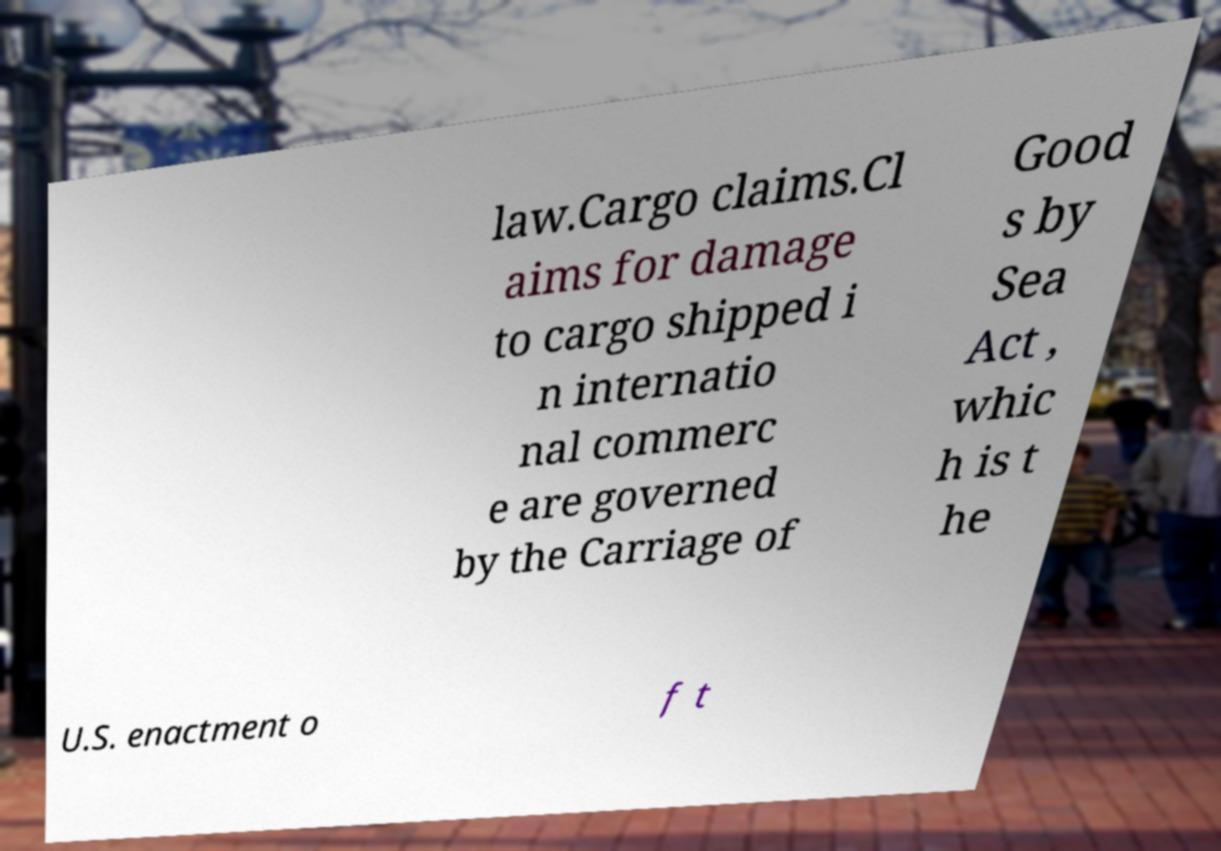Could you assist in decoding the text presented in this image and type it out clearly? law.Cargo claims.Cl aims for damage to cargo shipped i n internatio nal commerc e are governed by the Carriage of Good s by Sea Act , whic h is t he U.S. enactment o f t 